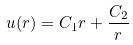Convert formula to latex. <formula><loc_0><loc_0><loc_500><loc_500>u ( r ) = C _ { 1 } r + \frac { C _ { 2 } } { r }</formula> 